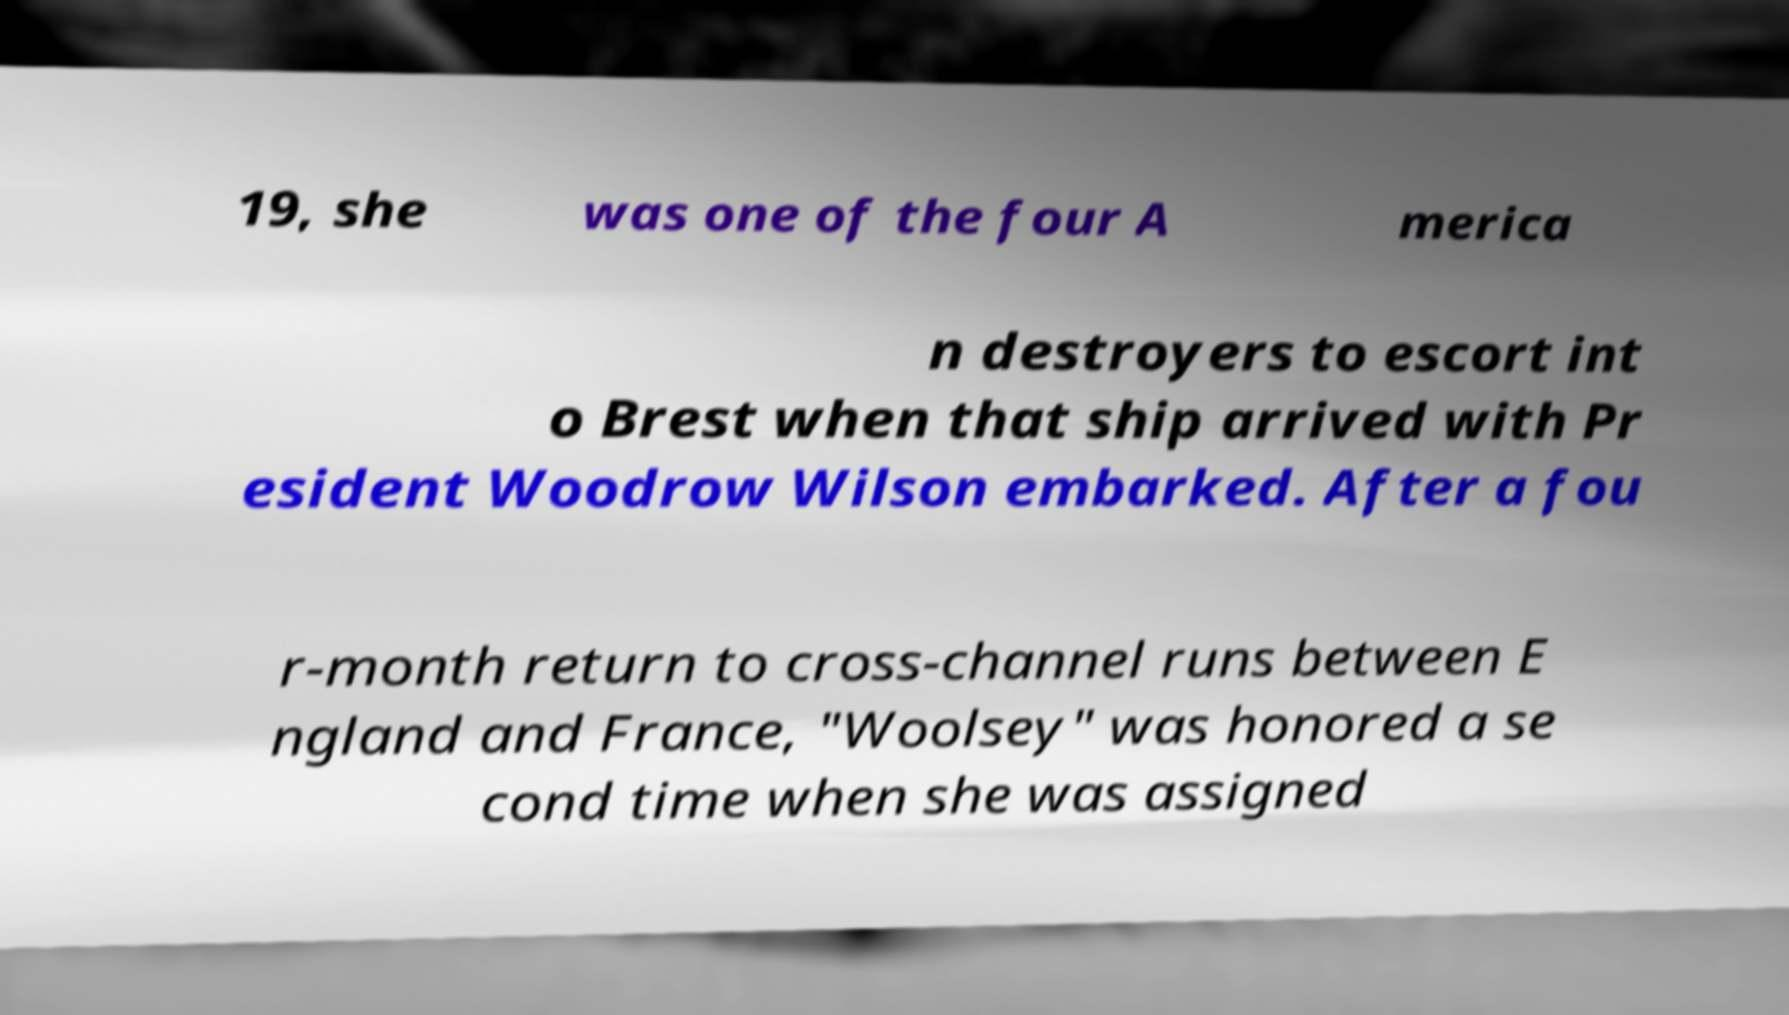Could you assist in decoding the text presented in this image and type it out clearly? 19, she was one of the four A merica n destroyers to escort int o Brest when that ship arrived with Pr esident Woodrow Wilson embarked. After a fou r-month return to cross-channel runs between E ngland and France, "Woolsey" was honored a se cond time when she was assigned 